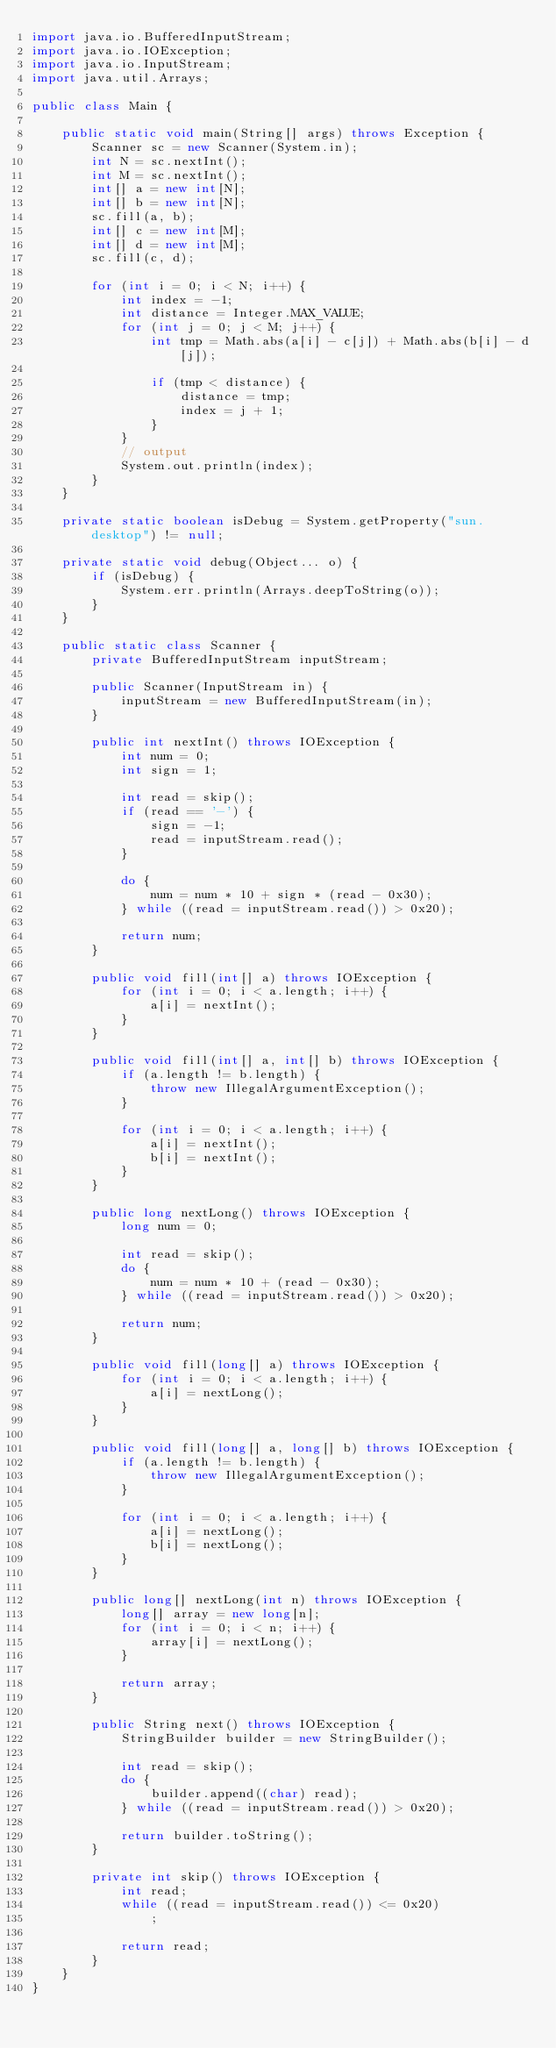Convert code to text. <code><loc_0><loc_0><loc_500><loc_500><_Java_>import java.io.BufferedInputStream;
import java.io.IOException;
import java.io.InputStream;
import java.util.Arrays;

public class Main {

	public static void main(String[] args) throws Exception {
		Scanner sc = new Scanner(System.in);
		int N = sc.nextInt();
		int M = sc.nextInt();
		int[] a = new int[N];
		int[] b = new int[N];
		sc.fill(a, b);
		int[] c = new int[M];
		int[] d = new int[M];
		sc.fill(c, d);

		for (int i = 0; i < N; i++) {
			int index = -1;
			int distance = Integer.MAX_VALUE;
			for (int j = 0; j < M; j++) {
				int tmp = Math.abs(a[i] - c[j]) + Math.abs(b[i] - d[j]);
				
				if (tmp < distance) {
					distance = tmp;
					index = j + 1;
				}
			}
			// output
			System.out.println(index);
		}
	}

	private static boolean isDebug = System.getProperty("sun.desktop") != null;

	private static void debug(Object... o) {
		if (isDebug) {
			System.err.println(Arrays.deepToString(o));
		}
	}

	public static class Scanner {
		private BufferedInputStream inputStream;

		public Scanner(InputStream in) {
			inputStream = new BufferedInputStream(in);
		}

		public int nextInt() throws IOException {
			int num = 0;
			int sign = 1;

			int read = skip();
			if (read == '-') {
				sign = -1;
				read = inputStream.read();
			}

			do {
				num = num * 10 + sign * (read - 0x30);
			} while ((read = inputStream.read()) > 0x20);

			return num;
		}

		public void fill(int[] a) throws IOException {
			for (int i = 0; i < a.length; i++) {
				a[i] = nextInt();
			}
		}

		public void fill(int[] a, int[] b) throws IOException {
			if (a.length != b.length) {
				throw new IllegalArgumentException();
			}

			for (int i = 0; i < a.length; i++) {
				a[i] = nextInt();
				b[i] = nextInt();
			}
		}

		public long nextLong() throws IOException {
			long num = 0;

			int read = skip();
			do {
				num = num * 10 + (read - 0x30);
			} while ((read = inputStream.read()) > 0x20);

			return num;
		}

		public void fill(long[] a) throws IOException {
			for (int i = 0; i < a.length; i++) {
				a[i] = nextLong();
			}
		}

		public void fill(long[] a, long[] b) throws IOException {
			if (a.length != b.length) {
				throw new IllegalArgumentException();
			}

			for (int i = 0; i < a.length; i++) {
				a[i] = nextLong();
				b[i] = nextLong();
			}
		}

		public long[] nextLong(int n) throws IOException {
			long[] array = new long[n];
			for (int i = 0; i < n; i++) {
				array[i] = nextLong();
			}

			return array;
		}

		public String next() throws IOException {
			StringBuilder builder = new StringBuilder();

			int read = skip();
			do {
				builder.append((char) read);
			} while ((read = inputStream.read()) > 0x20);

			return builder.toString();
		}

		private int skip() throws IOException {
			int read;
			while ((read = inputStream.read()) <= 0x20)
				;

			return read;
		}
	}
}
</code> 